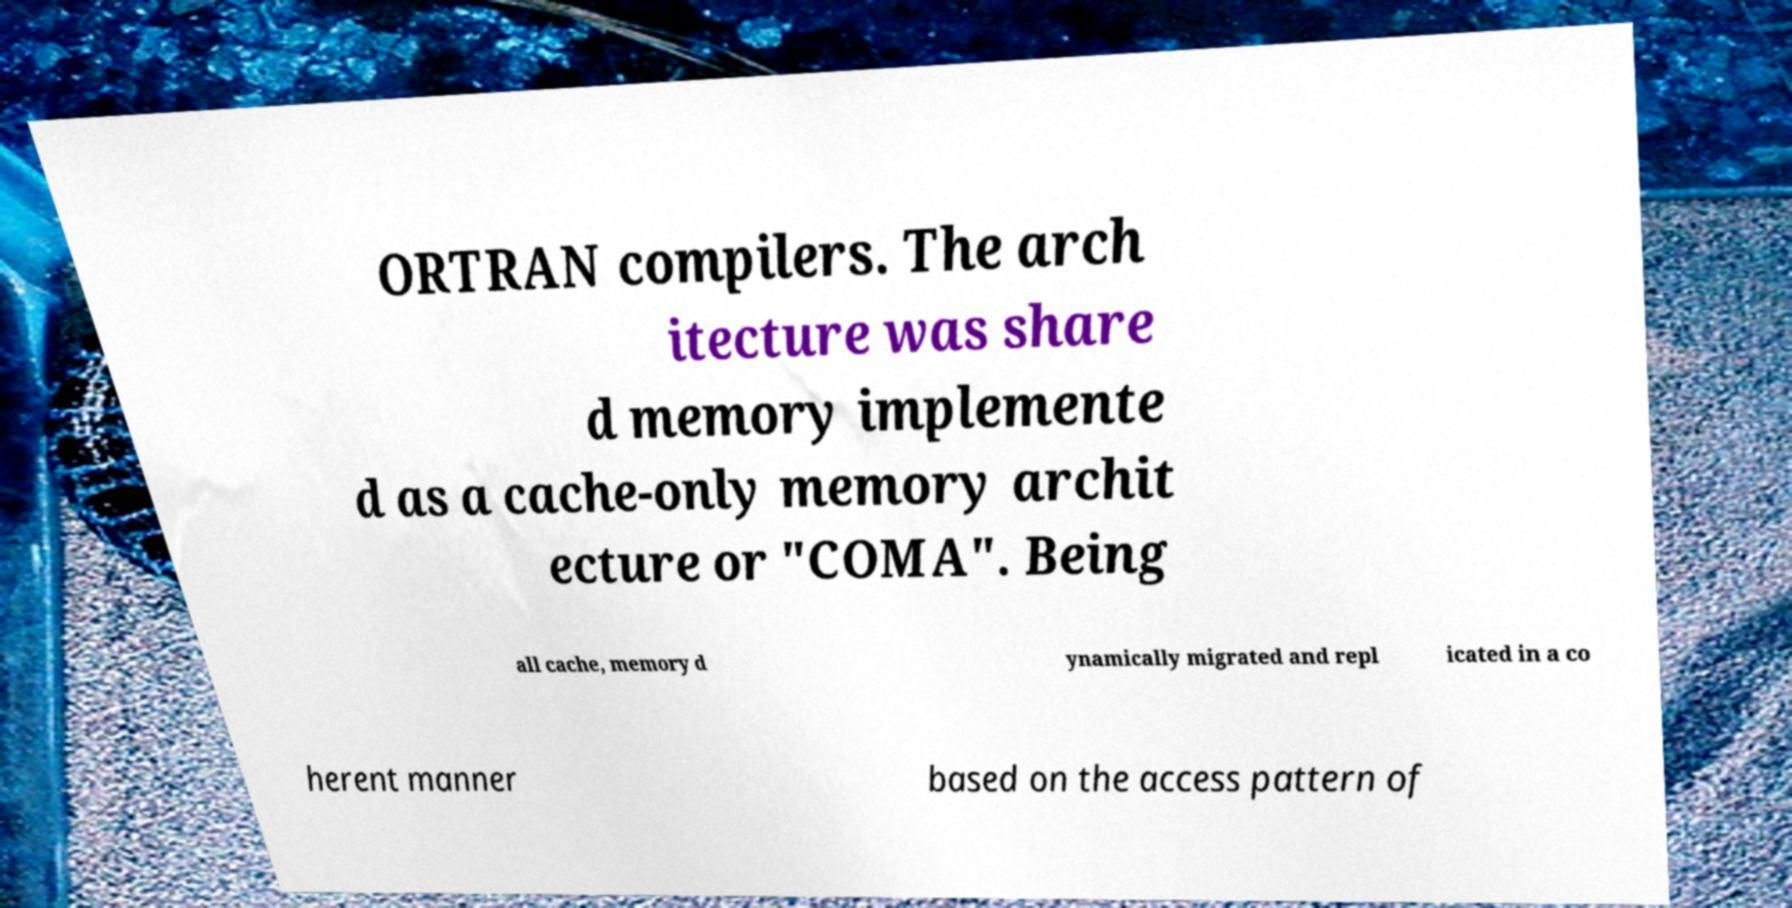What messages or text are displayed in this image? I need them in a readable, typed format. ORTRAN compilers. The arch itecture was share d memory implemente d as a cache-only memory archit ecture or "COMA". Being all cache, memory d ynamically migrated and repl icated in a co herent manner based on the access pattern of 